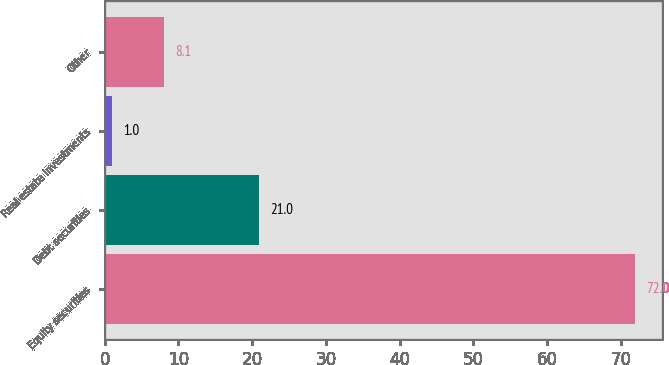Convert chart to OTSL. <chart><loc_0><loc_0><loc_500><loc_500><bar_chart><fcel>Equity securities<fcel>Debt securities<fcel>Real estate investments<fcel>Other<nl><fcel>72<fcel>21<fcel>1<fcel>8.1<nl></chart> 